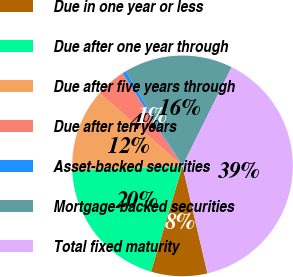Convert chart. <chart><loc_0><loc_0><loc_500><loc_500><pie_chart><fcel>Due in one year or less<fcel>Due after one year through<fcel>Due after five years through<fcel>Due after ten years<fcel>Asset-backed securities<fcel>Mortgage-backed securities<fcel>Total fixed maturity<nl><fcel>8.24%<fcel>19.78%<fcel>12.09%<fcel>4.39%<fcel>0.55%<fcel>15.93%<fcel>39.02%<nl></chart> 